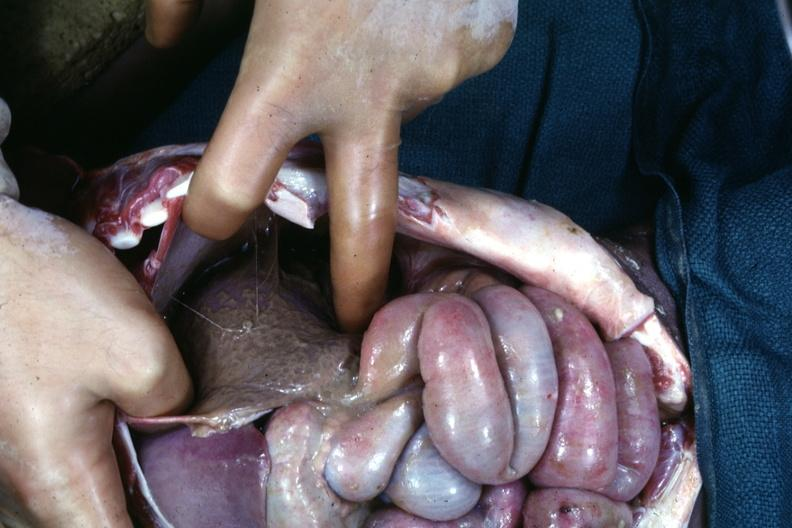does this image show an opened peritoneal cavity cause by fibrous band strangulation see other slides?
Answer the question using a single word or phrase. Yes 